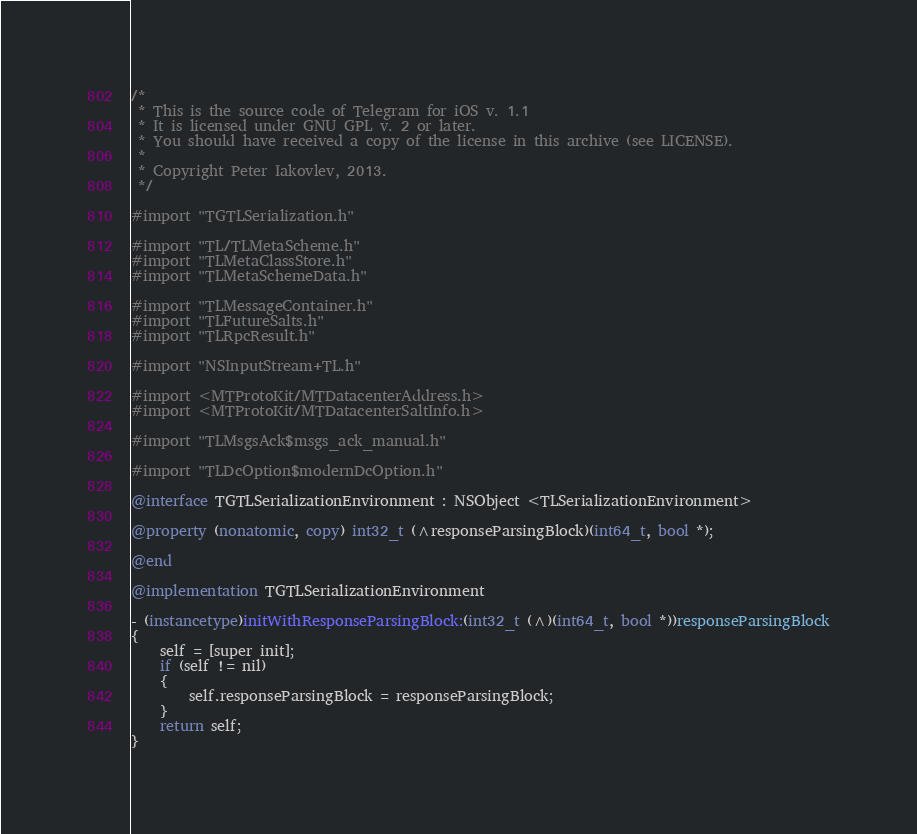<code> <loc_0><loc_0><loc_500><loc_500><_ObjectiveC_>/*
 * This is the source code of Telegram for iOS v. 1.1
 * It is licensed under GNU GPL v. 2 or later.
 * You should have received a copy of the license in this archive (see LICENSE).
 *
 * Copyright Peter Iakovlev, 2013.
 */

#import "TGTLSerialization.h"

#import "TL/TLMetaScheme.h"
#import "TLMetaClassStore.h"
#import "TLMetaSchemeData.h"

#import "TLMessageContainer.h"
#import "TLFutureSalts.h"
#import "TLRpcResult.h"

#import "NSInputStream+TL.h"

#import <MTProtoKit/MTDatacenterAddress.h>
#import <MTProtoKit/MTDatacenterSaltInfo.h>

#import "TLMsgsAck$msgs_ack_manual.h"

#import "TLDcOption$modernDcOption.h"

@interface TGTLSerializationEnvironment : NSObject <TLSerializationEnvironment>

@property (nonatomic, copy) int32_t (^responseParsingBlock)(int64_t, bool *);

@end

@implementation TGTLSerializationEnvironment

- (instancetype)initWithResponseParsingBlock:(int32_t (^)(int64_t, bool *))responseParsingBlock
{
    self = [super init];
    if (self != nil)
    {
        self.responseParsingBlock = responseParsingBlock;
    }
    return self;
}
</code> 